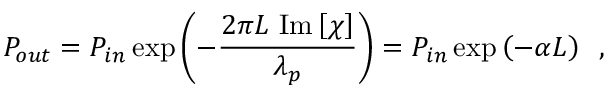Convert formula to latex. <formula><loc_0><loc_0><loc_500><loc_500>P _ { o u t } = P _ { i n } \exp \left ( - \frac { 2 \pi L \, I m \left [ \chi \right ] } { \lambda _ { p } } \right ) = P _ { i n } \exp \left ( - \alpha L \right ) \, ,</formula> 